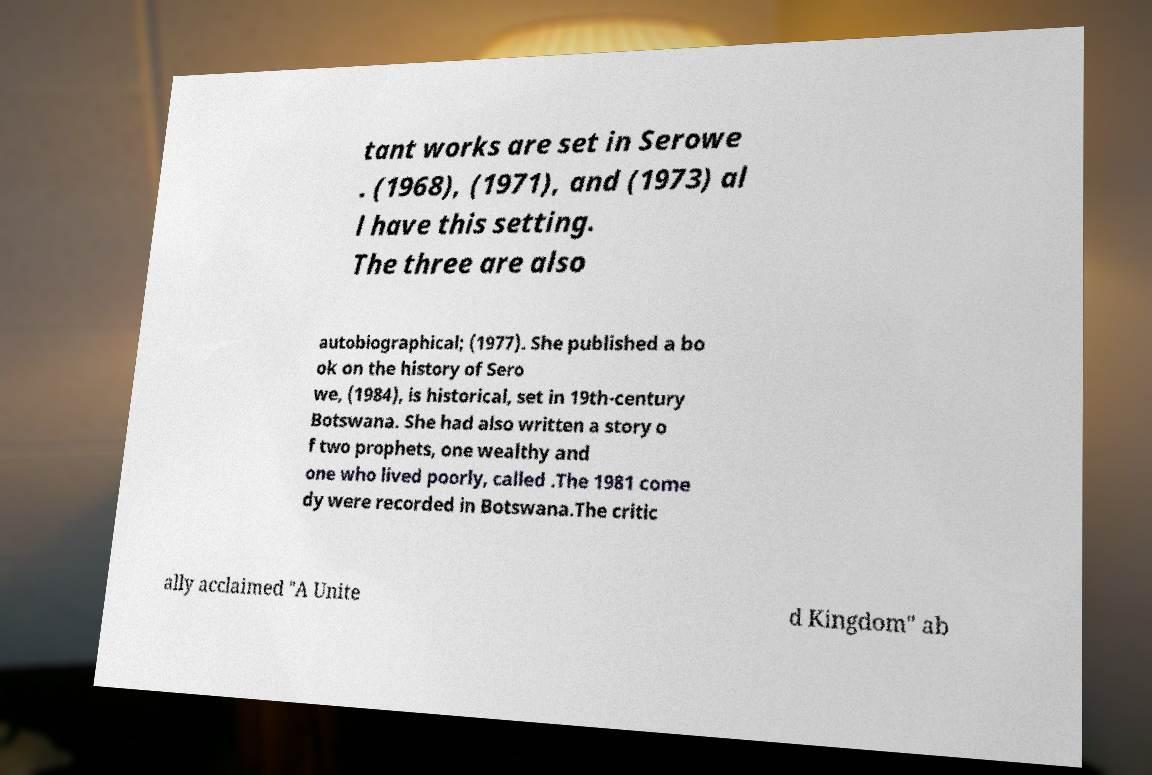Can you accurately transcribe the text from the provided image for me? tant works are set in Serowe . (1968), (1971), and (1973) al l have this setting. The three are also autobiographical; (1977). She published a bo ok on the history of Sero we, (1984), is historical, set in 19th-century Botswana. She had also written a story o f two prophets, one wealthy and one who lived poorly, called .The 1981 come dy were recorded in Botswana.The critic ally acclaimed "A Unite d Kingdom" ab 